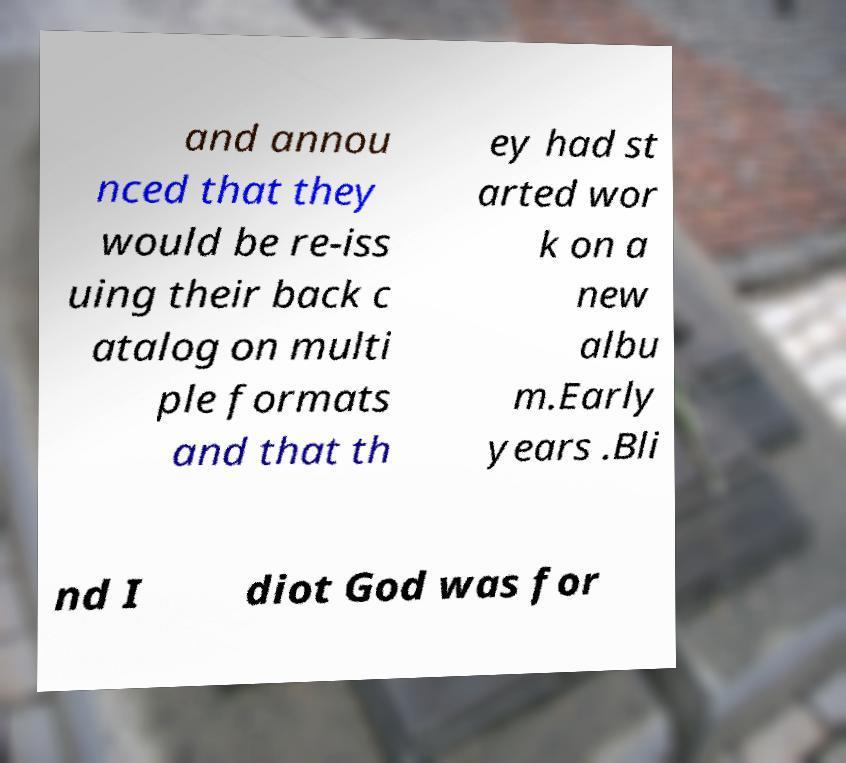What messages or text are displayed in this image? I need them in a readable, typed format. and annou nced that they would be re-iss uing their back c atalog on multi ple formats and that th ey had st arted wor k on a new albu m.Early years .Bli nd I diot God was for 